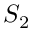<formula> <loc_0><loc_0><loc_500><loc_500>S _ { 2 }</formula> 